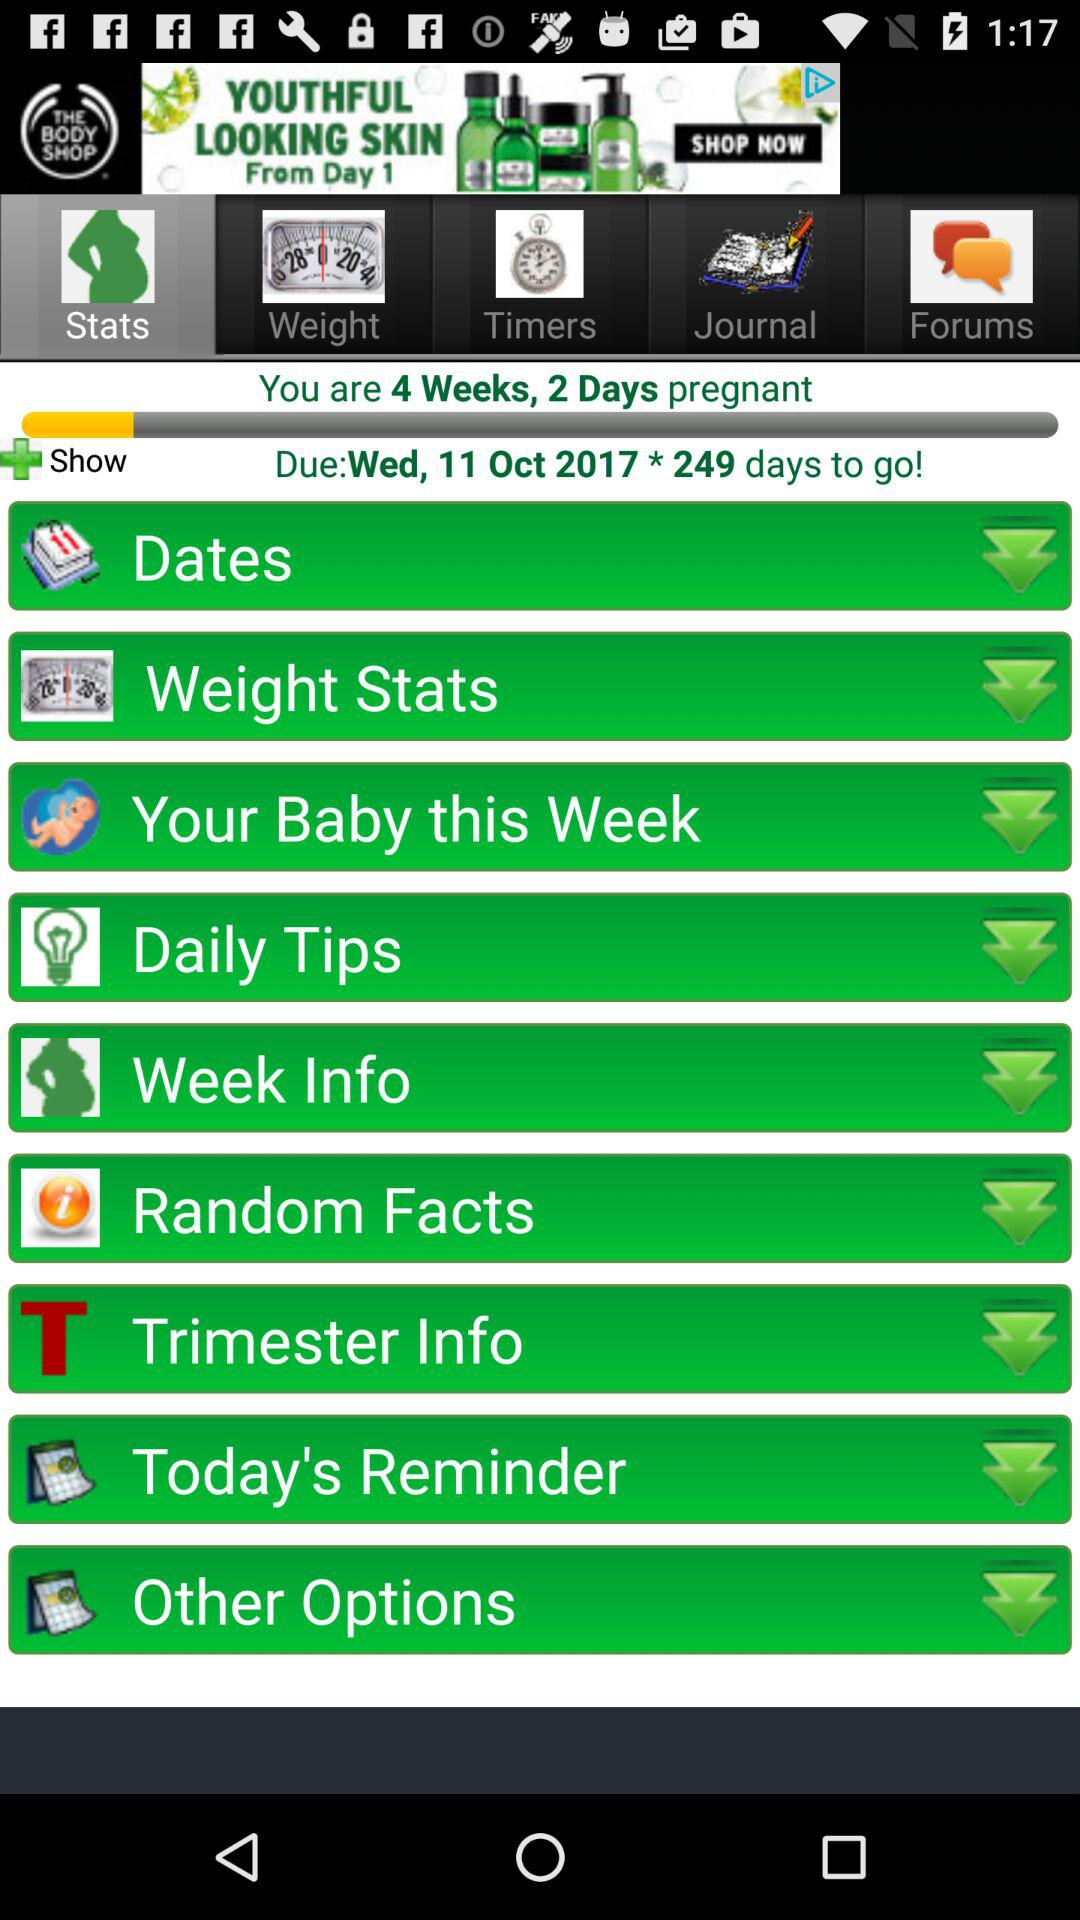How many days are left? There are 249 days left. 